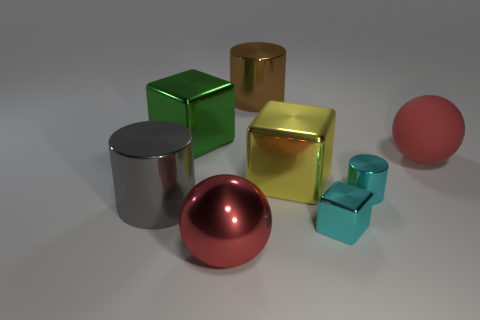Subtract all large gray cylinders. How many cylinders are left? 2 Subtract all cyan cylinders. How many cylinders are left? 2 Subtract all purple cylinders. Subtract all brown blocks. How many cylinders are left? 3 Subtract all green spheres. How many yellow cubes are left? 1 Subtract all yellow matte balls. Subtract all big brown objects. How many objects are left? 7 Add 5 cubes. How many cubes are left? 8 Add 8 large blue things. How many large blue things exist? 8 Add 2 gray metallic things. How many objects exist? 10 Subtract 1 gray cylinders. How many objects are left? 7 Subtract all cubes. How many objects are left? 5 